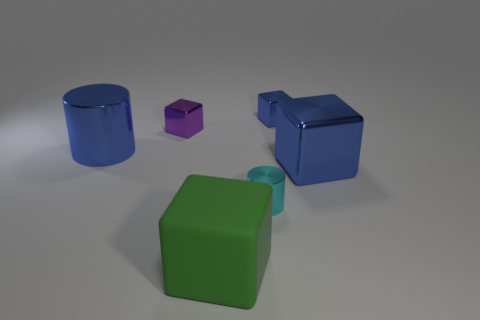Add 4 large things. How many objects exist? 10 Subtract 0 purple spheres. How many objects are left? 6 Subtract all cylinders. How many objects are left? 4 Subtract 1 cubes. How many cubes are left? 3 Subtract all blue cylinders. Subtract all blue blocks. How many cylinders are left? 1 Subtract all brown spheres. How many brown cubes are left? 0 Subtract all large rubber things. Subtract all cyan metal cylinders. How many objects are left? 4 Add 4 shiny cylinders. How many shiny cylinders are left? 6 Add 5 purple things. How many purple things exist? 6 Subtract all cyan cylinders. How many cylinders are left? 1 